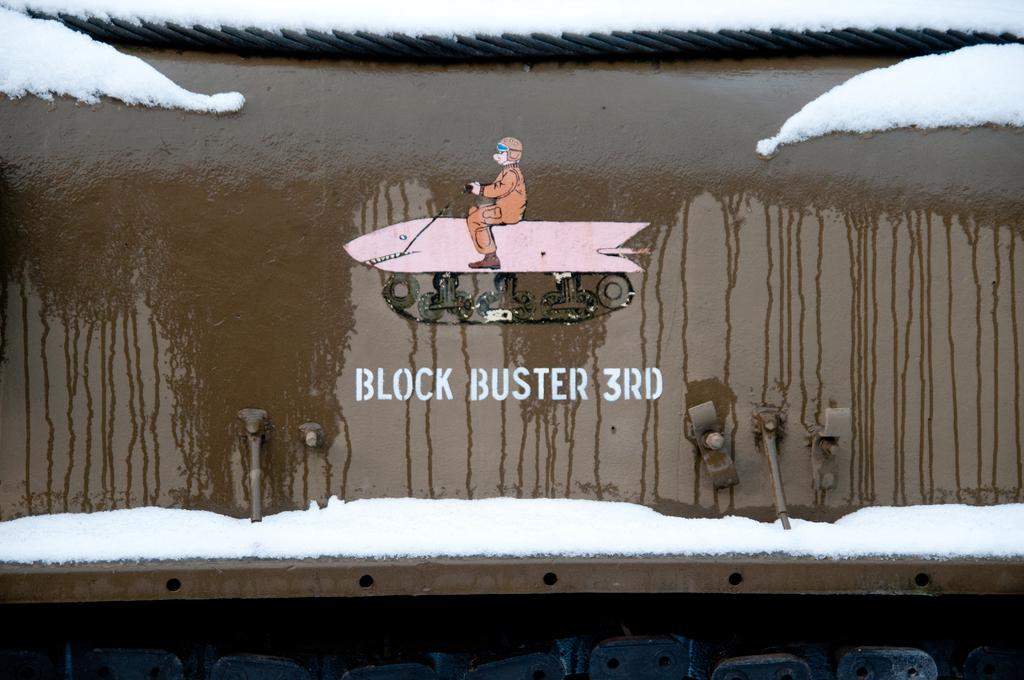What is this writing in reference to?
Give a very brief answer. Block buster 3rd. What is the number on here?
Give a very brief answer. 3. 